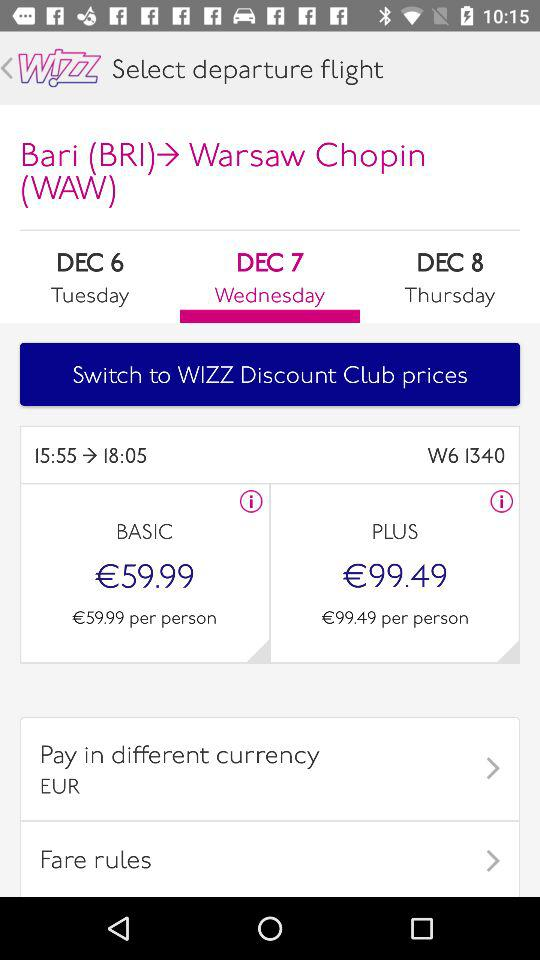What is the price of a flight ticket in the "BASIC" category? The price of a flight ticket in the "BASIC" category is €59.99. 